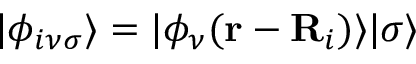<formula> <loc_0><loc_0><loc_500><loc_500>| \phi _ { i \nu \sigma } \rangle = | \phi _ { \nu } ( { r } - { R } _ { i } ) \rangle | \sigma \rangle</formula> 